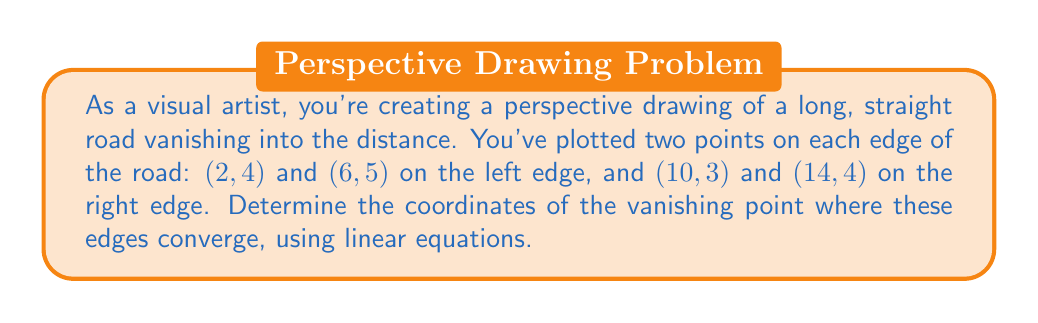Could you help me with this problem? To find the vanishing point, we need to:

1. Find the equations of the lines representing the road edges.
2. Solve for the intersection of these lines.

For the left edge:
Let's call this line $L_1$. We can use the point-slope form:
$$ y - y_1 = m_1(x - x_1) $$

The slope $m_1 = \frac{5-4}{6-2} = \frac{1}{4}$

Using the point $(2, 4)$:
$$ y - 4 = \frac{1}{4}(x - 2) $$
$$ y = \frac{1}{4}x + \frac{7}{2} $$

For the right edge:
Let's call this line $L_2$. Again, using point-slope form:

The slope $m_2 = \frac{4-3}{14-10} = \frac{1}{4}$

Using the point $(10, 3)$:
$$ y - 3 = \frac{1}{4}(x - 10) $$
$$ y = \frac{1}{4}x + \frac{1}{2} $$

To find the intersection, set the equations equal:
$$ \frac{1}{4}x + \frac{7}{2} = \frac{1}{4}x + \frac{1}{2} $$

Simplifying:
$$ \frac{7}{2} = \frac{1}{2} $$

This is always true, meaning the lines are parallel and never intersect. In perspective drawing, parallel lines converge at infinity. Therefore, the vanishing point is at infinity along the x-axis.

In artistic terms, this means the vanishing point is on the horizon line, infinitely far to the right.
Answer: $(∞, 4)$ 